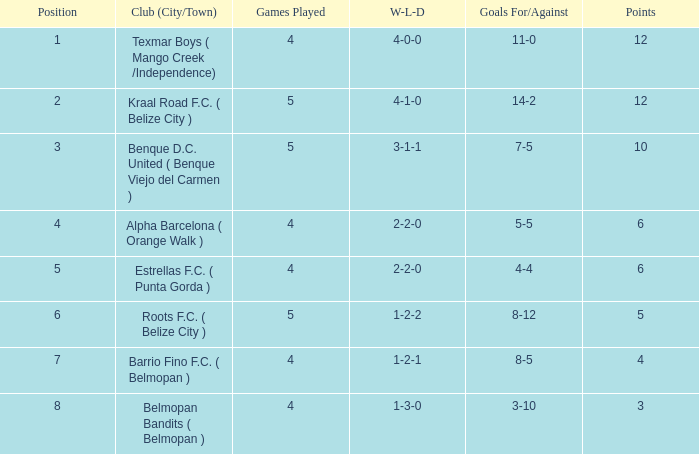What is the club from the city/town with a 14-2 record in terms of goals scored and conceded? Kraal Road F.C. ( Belize City ). 